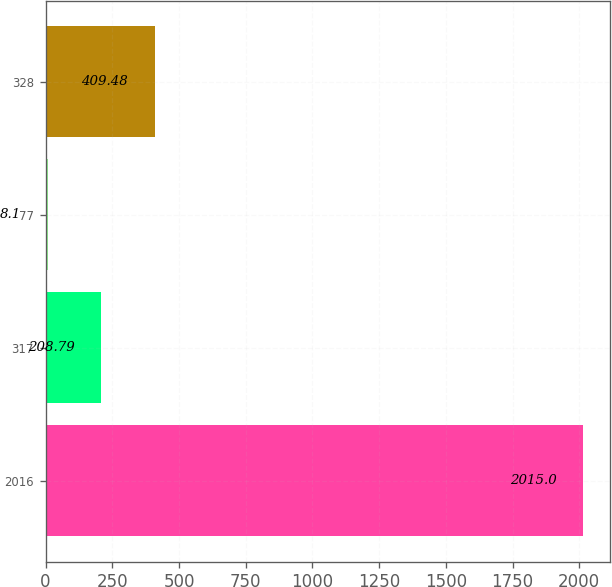Convert chart. <chart><loc_0><loc_0><loc_500><loc_500><bar_chart><fcel>2016<fcel>317<fcel>77<fcel>328<nl><fcel>2015<fcel>208.79<fcel>8.1<fcel>409.48<nl></chart> 